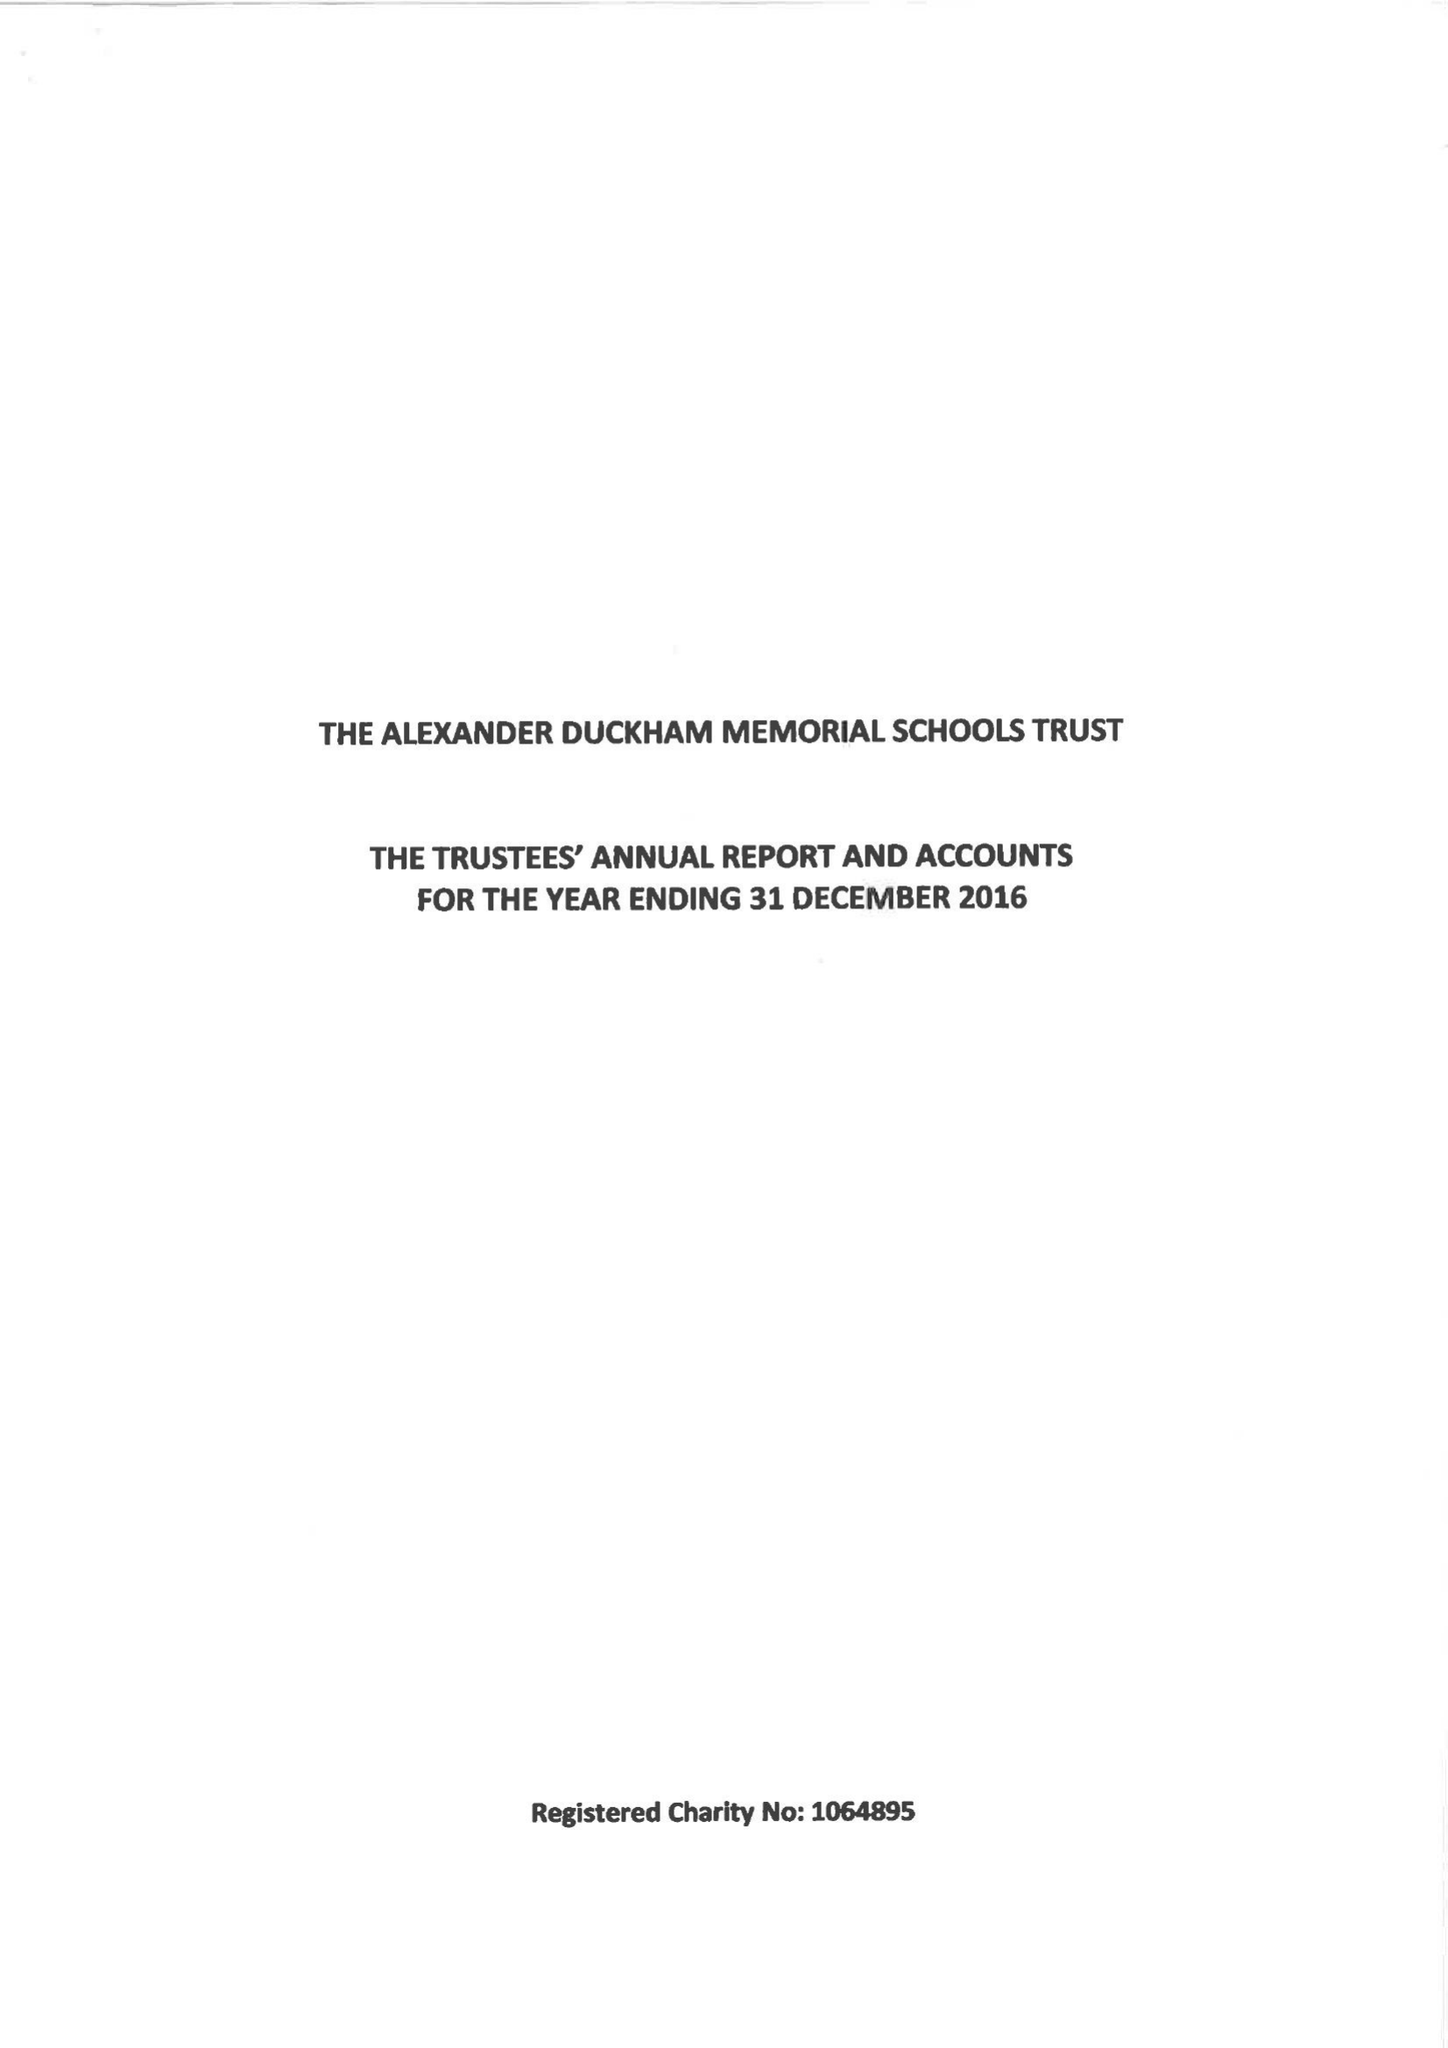What is the value for the address__postcode?
Answer the question using a single word or phrase. SW15 6RU 